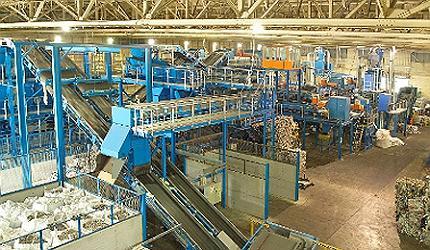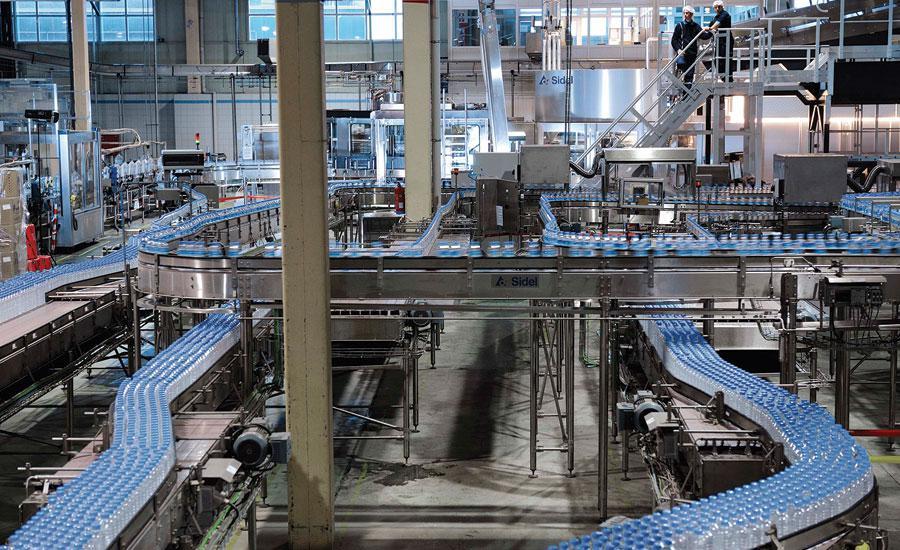The first image is the image on the left, the second image is the image on the right. Considering the images on both sides, is "A person in an orange shirt stands near a belt of bottles." valid? Answer yes or no. No. 